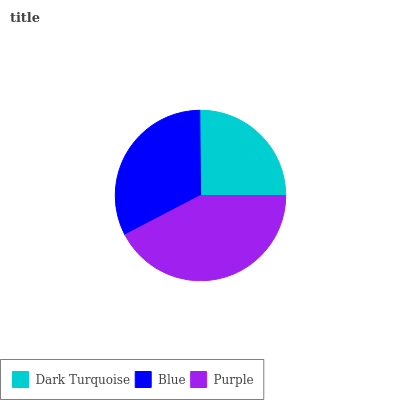Is Dark Turquoise the minimum?
Answer yes or no. Yes. Is Purple the maximum?
Answer yes or no. Yes. Is Blue the minimum?
Answer yes or no. No. Is Blue the maximum?
Answer yes or no. No. Is Blue greater than Dark Turquoise?
Answer yes or no. Yes. Is Dark Turquoise less than Blue?
Answer yes or no. Yes. Is Dark Turquoise greater than Blue?
Answer yes or no. No. Is Blue less than Dark Turquoise?
Answer yes or no. No. Is Blue the high median?
Answer yes or no. Yes. Is Blue the low median?
Answer yes or no. Yes. Is Purple the high median?
Answer yes or no. No. Is Purple the low median?
Answer yes or no. No. 